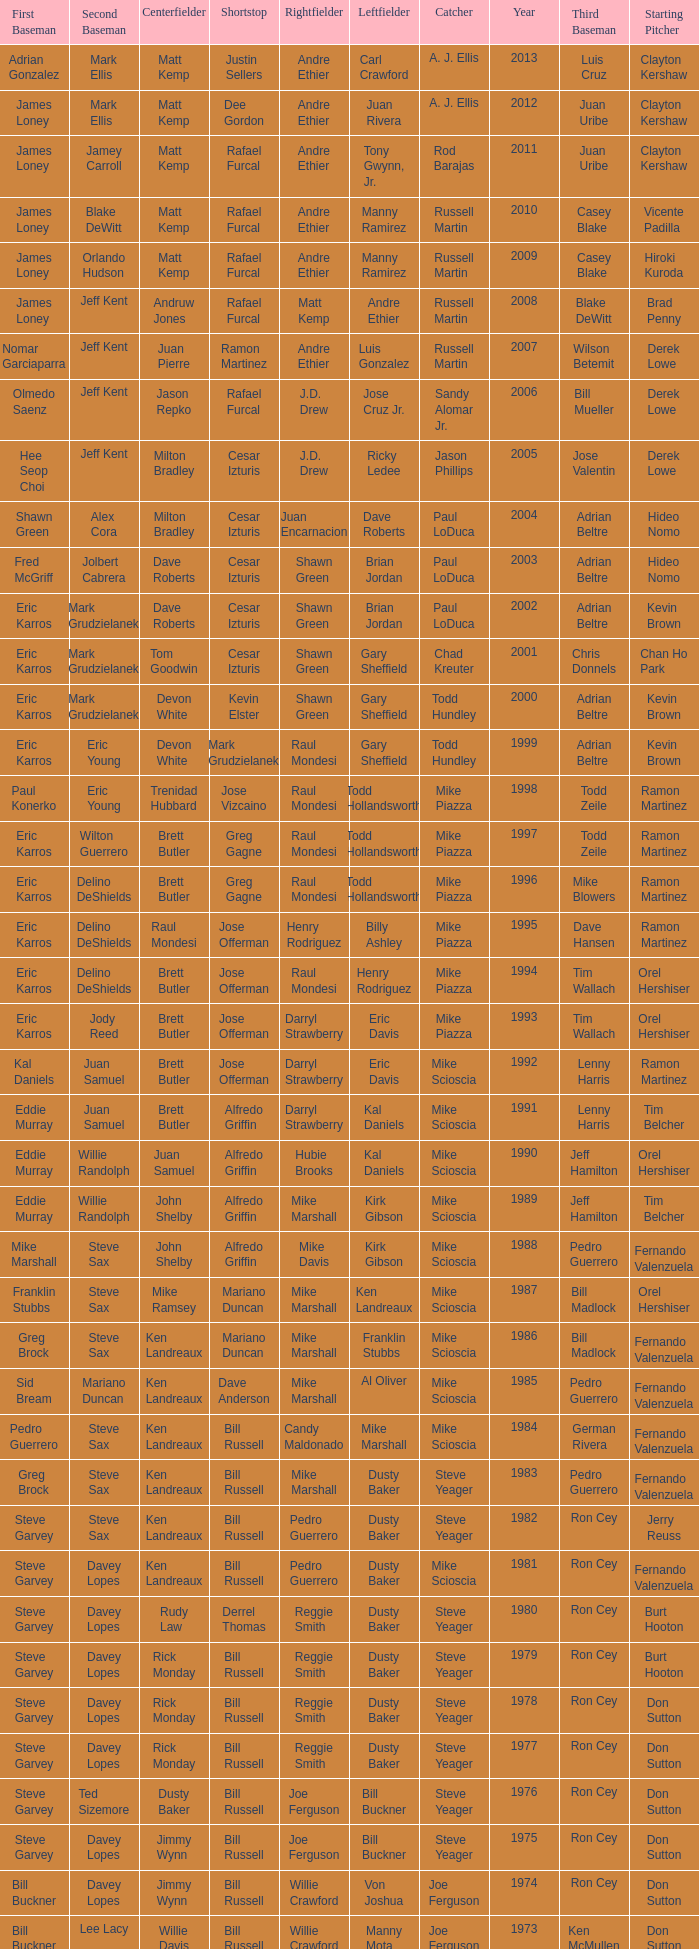Who was the RF when the SP was vicente padilla? Andre Ethier. 